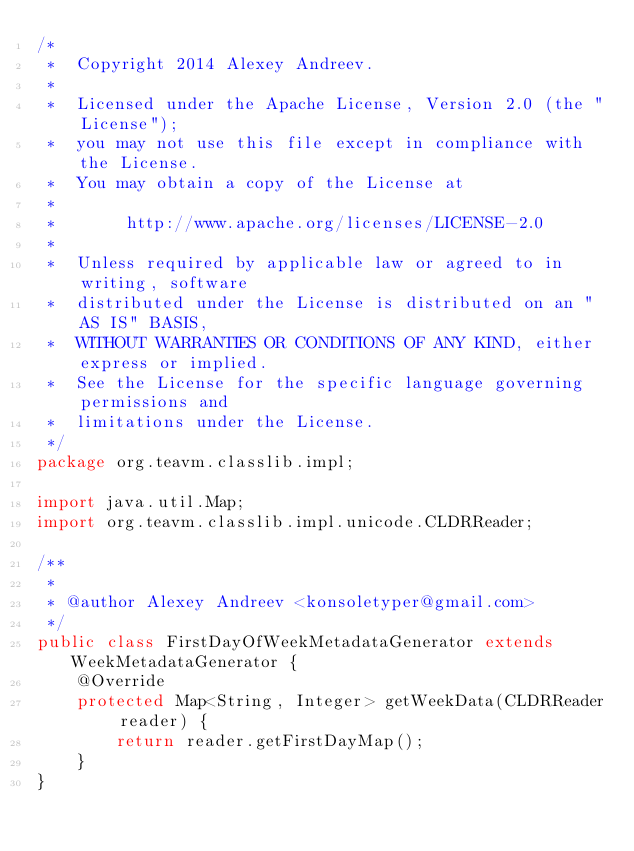Convert code to text. <code><loc_0><loc_0><loc_500><loc_500><_Java_>/*
 *  Copyright 2014 Alexey Andreev.
 *
 *  Licensed under the Apache License, Version 2.0 (the "License");
 *  you may not use this file except in compliance with the License.
 *  You may obtain a copy of the License at
 *
 *       http://www.apache.org/licenses/LICENSE-2.0
 *
 *  Unless required by applicable law or agreed to in writing, software
 *  distributed under the License is distributed on an "AS IS" BASIS,
 *  WITHOUT WARRANTIES OR CONDITIONS OF ANY KIND, either express or implied.
 *  See the License for the specific language governing permissions and
 *  limitations under the License.
 */
package org.teavm.classlib.impl;

import java.util.Map;
import org.teavm.classlib.impl.unicode.CLDRReader;

/**
 *
 * @author Alexey Andreev <konsoletyper@gmail.com>
 */
public class FirstDayOfWeekMetadataGenerator extends WeekMetadataGenerator {
    @Override
    protected Map<String, Integer> getWeekData(CLDRReader reader) {
        return reader.getFirstDayMap();
    }
}
</code> 